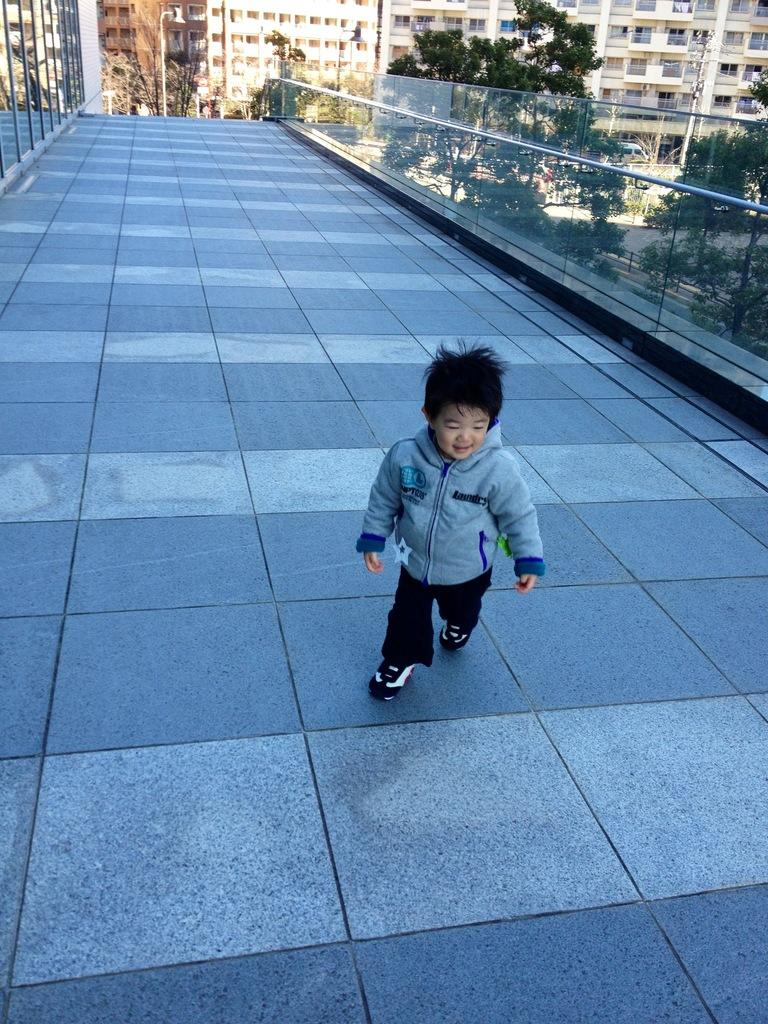What is the kid doing in the image? The kid is standing and smiling in the image. What can be seen in the distance behind the kid? There are buildings, poles, lights, and trees in the background of the image. What type of cream is being used to paint the trees in the image? There is no cream or painting activity present in the image; the trees are natural and not painted. 